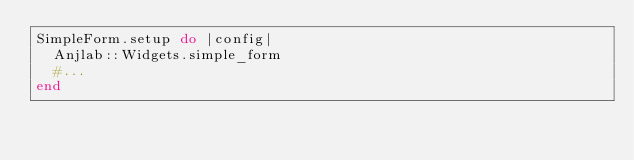<code> <loc_0><loc_0><loc_500><loc_500><_Ruby_>SimpleForm.setup do |config|
  Anjlab::Widgets.simple_form
  #...
end</code> 